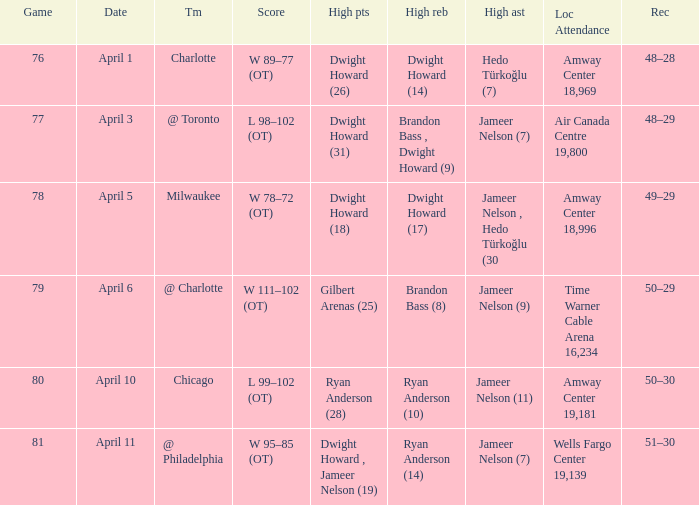On april 1, who recorded the highest number of rebounds and what was the total count? Dwight Howard (14). 